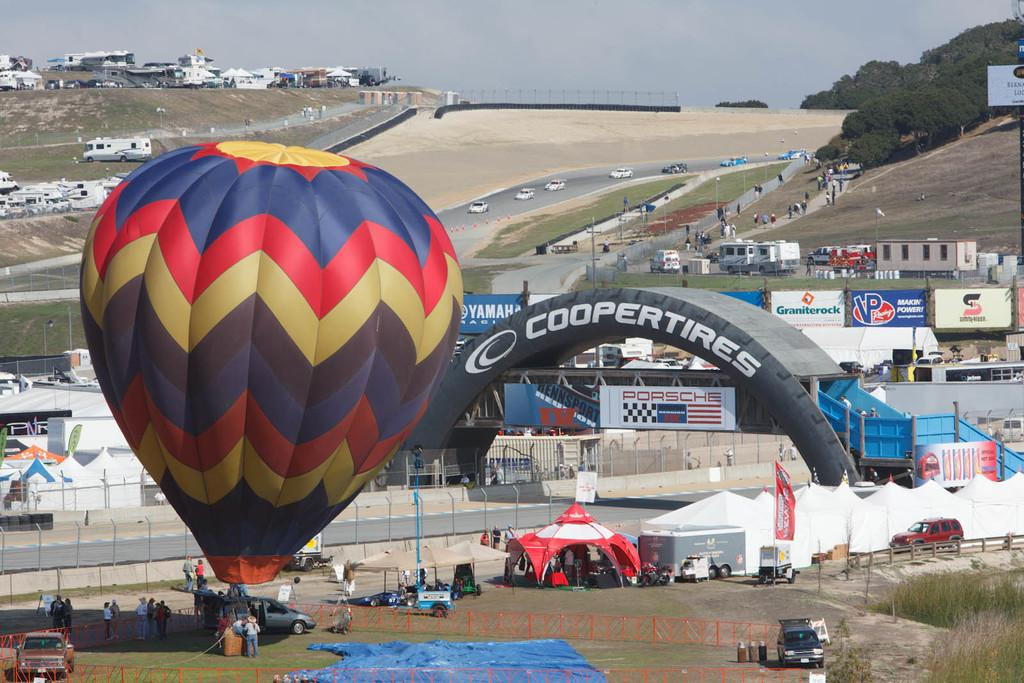<image>
Write a terse but informative summary of the picture. The racing event is sponsored by Cooper Tires and Porsche. 